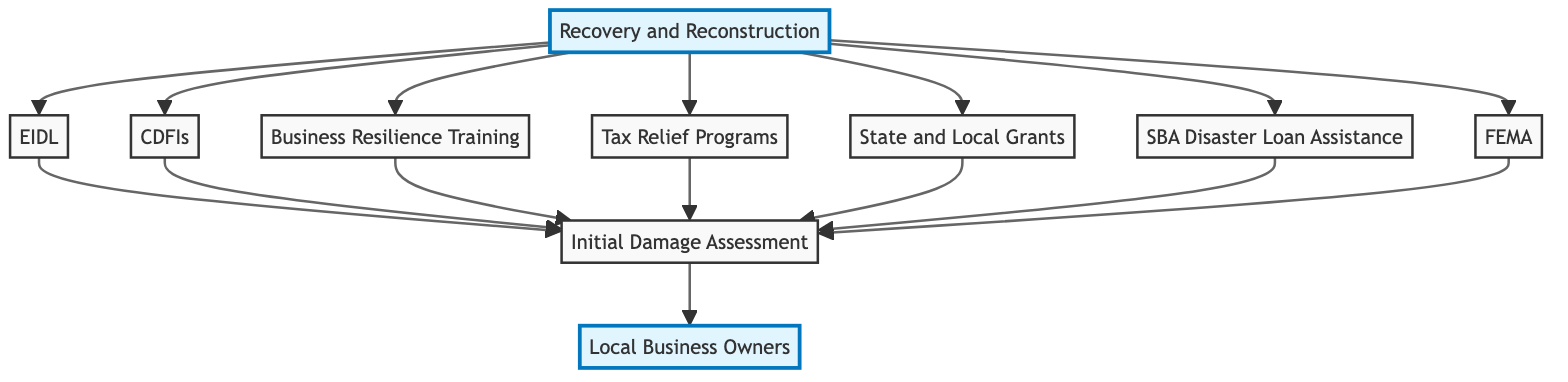What is the top node in the diagram? The top node in the diagram is the 'Local Business Owners'. This is determined by identifying the starting point of the flow, which ultimately leads to the local businesses that are being supported by various government programs in the aftermath of the disaster.
Answer: Local Business Owners How many government support programs are listed? By counting each of the government support programs presented in the diagram (C, D, E, F, G, H, I), there are a total of 7 distinct programs mentioned that flow into the recovery and reconstruction assistance.
Answer: 7 Which node provides recovery and reconstruction assistance? The 'Recovery and Reconstruction Assistance' node is identified specifically by its label in the diagram, which indicates it serves as a comprehensive support for rebuilding and relaunching business operations after a disaster.
Answer: Recovery and Reconstruction Assistance What connects all the programs to the initial damage assessment? All programs (C, D, E, F, G, H, I) are directed towards the 'Initial Damage Assessment' node, representing the process where the extent of damage is evaluated and thus connects the assessment process to all forms of assistance that follow it.
Answer: Initial Damage Assessment Which program specifically offers low-interest loans? The 'SBA Disaster Loan Assistance' node is specified in the diagram to provide low-interest loans to affected businesses, as indicated by its description under the node label.
Answer: SBA Disaster Loan Assistance What type of program is represented by the node labeled CDFIs? The 'Community Development Financial Institutions (CDFIs)' provides financial services to low-income or underserved communities, as referenced by the specific label and description associated with that node in the diagram.
Answer: Financial services What is the purpose of the Tax Relief Programs node? The 'Tax Relief Programs' node is intended for the deferment or reduction of tax liabilities for businesses affected by the disaster, as conveyed through its description in the diagram.
Answer: Deferment or reduction of tax liabilities How do businesses assess damages? Businesses assess damages through the 'Initial Damage Assessment' node, which illustrates the evaluation process and relationship to the necessary support following a disaster.
Answer: Initial Damage Assessment What happens after the recovery and reconstruction assistance? After the 'Recovery and Reconstruction Assistance', the flow shows that entities like Economic Injury Disaster Loans and CDFIs support businesses in returning to operation through financial means, as shown by the outflow arrows leading from that node.
Answer: Financial support 